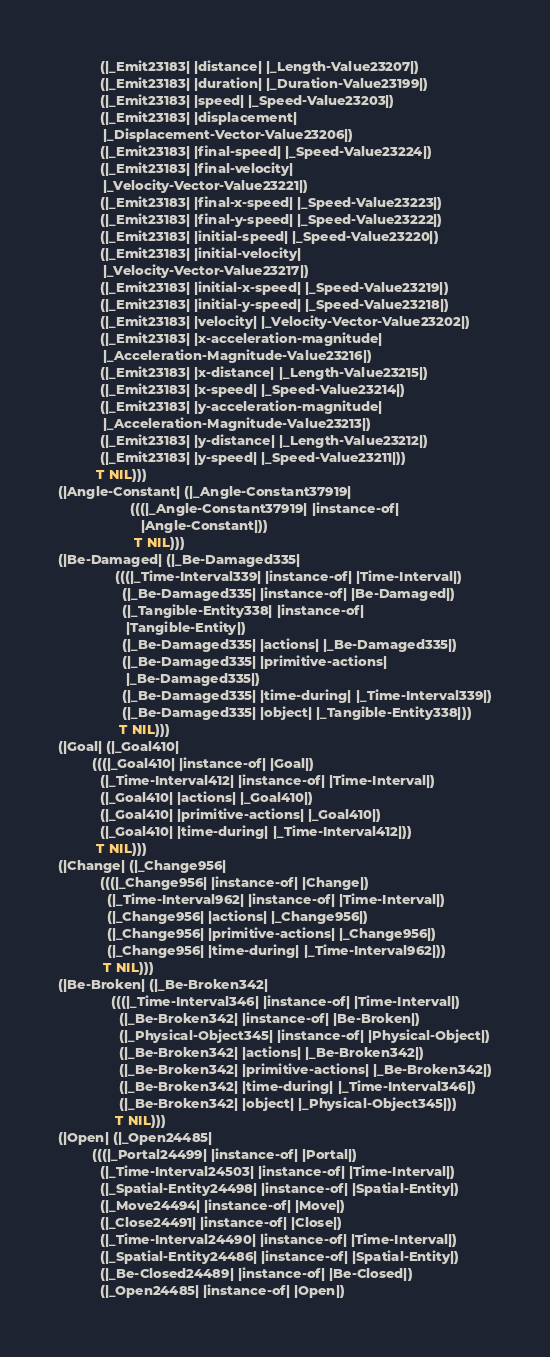Convert code to text. <code><loc_0><loc_0><loc_500><loc_500><_Lisp_>           (|_Emit23183| |distance| |_Length-Value23207|)
           (|_Emit23183| |duration| |_Duration-Value23199|)
           (|_Emit23183| |speed| |_Speed-Value23203|)
           (|_Emit23183| |displacement|
            |_Displacement-Vector-Value23206|)
           (|_Emit23183| |final-speed| |_Speed-Value23224|)
           (|_Emit23183| |final-velocity|
            |_Velocity-Vector-Value23221|)
           (|_Emit23183| |final-x-speed| |_Speed-Value23223|)
           (|_Emit23183| |final-y-speed| |_Speed-Value23222|)
           (|_Emit23183| |initial-speed| |_Speed-Value23220|)
           (|_Emit23183| |initial-velocity|
            |_Velocity-Vector-Value23217|)
           (|_Emit23183| |initial-x-speed| |_Speed-Value23219|)
           (|_Emit23183| |initial-y-speed| |_Speed-Value23218|)
           (|_Emit23183| |velocity| |_Velocity-Vector-Value23202|)
           (|_Emit23183| |x-acceleration-magnitude|
            |_Acceleration-Magnitude-Value23216|)
           (|_Emit23183| |x-distance| |_Length-Value23215|)
           (|_Emit23183| |x-speed| |_Speed-Value23214|)
           (|_Emit23183| |y-acceleration-magnitude|
            |_Acceleration-Magnitude-Value23213|)
           (|_Emit23183| |y-distance| |_Length-Value23212|)
           (|_Emit23183| |y-speed| |_Speed-Value23211|))
          T NIL)))
(|Angle-Constant| (|_Angle-Constant37919|
                   (((|_Angle-Constant37919| |instance-of|
                      |Angle-Constant|))
                    T NIL)))
(|Be-Damaged| (|_Be-Damaged335|
               (((|_Time-Interval339| |instance-of| |Time-Interval|)
                 (|_Be-Damaged335| |instance-of| |Be-Damaged|)
                 (|_Tangible-Entity338| |instance-of|
                  |Tangible-Entity|)
                 (|_Be-Damaged335| |actions| |_Be-Damaged335|)
                 (|_Be-Damaged335| |primitive-actions|
                  |_Be-Damaged335|)
                 (|_Be-Damaged335| |time-during| |_Time-Interval339|)
                 (|_Be-Damaged335| |object| |_Tangible-Entity338|))
                T NIL)))
(|Goal| (|_Goal410|
         (((|_Goal410| |instance-of| |Goal|)
           (|_Time-Interval412| |instance-of| |Time-Interval|)
           (|_Goal410| |actions| |_Goal410|)
           (|_Goal410| |primitive-actions| |_Goal410|)
           (|_Goal410| |time-during| |_Time-Interval412|))
          T NIL)))
(|Change| (|_Change956|
           (((|_Change956| |instance-of| |Change|)
             (|_Time-Interval962| |instance-of| |Time-Interval|)
             (|_Change956| |actions| |_Change956|)
             (|_Change956| |primitive-actions| |_Change956|)
             (|_Change956| |time-during| |_Time-Interval962|))
            T NIL)))
(|Be-Broken| (|_Be-Broken342|
              (((|_Time-Interval346| |instance-of| |Time-Interval|)
                (|_Be-Broken342| |instance-of| |Be-Broken|)
                (|_Physical-Object345| |instance-of| |Physical-Object|)
                (|_Be-Broken342| |actions| |_Be-Broken342|)
                (|_Be-Broken342| |primitive-actions| |_Be-Broken342|)
                (|_Be-Broken342| |time-during| |_Time-Interval346|)
                (|_Be-Broken342| |object| |_Physical-Object345|))
               T NIL)))
(|Open| (|_Open24485|
         (((|_Portal24499| |instance-of| |Portal|)
           (|_Time-Interval24503| |instance-of| |Time-Interval|)
           (|_Spatial-Entity24498| |instance-of| |Spatial-Entity|)
           (|_Move24494| |instance-of| |Move|)
           (|_Close24491| |instance-of| |Close|)
           (|_Time-Interval24490| |instance-of| |Time-Interval|)
           (|_Spatial-Entity24486| |instance-of| |Spatial-Entity|)
           (|_Be-Closed24489| |instance-of| |Be-Closed|)
           (|_Open24485| |instance-of| |Open|)</code> 